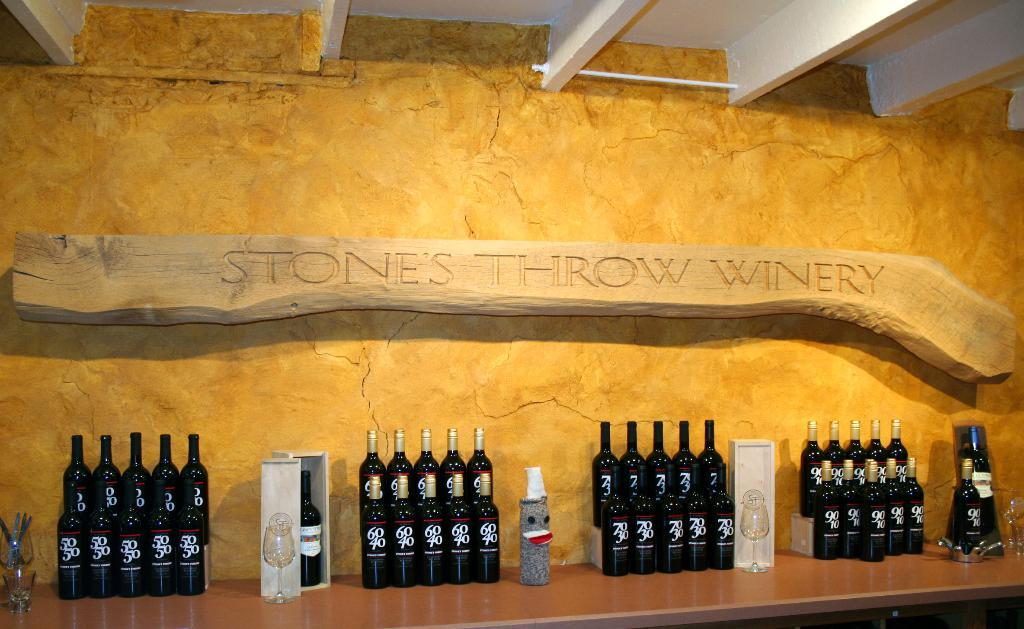<image>
Render a clear and concise summary of the photo. a counter full of bottles with a sign above it that says 'stones throw winery' on it 